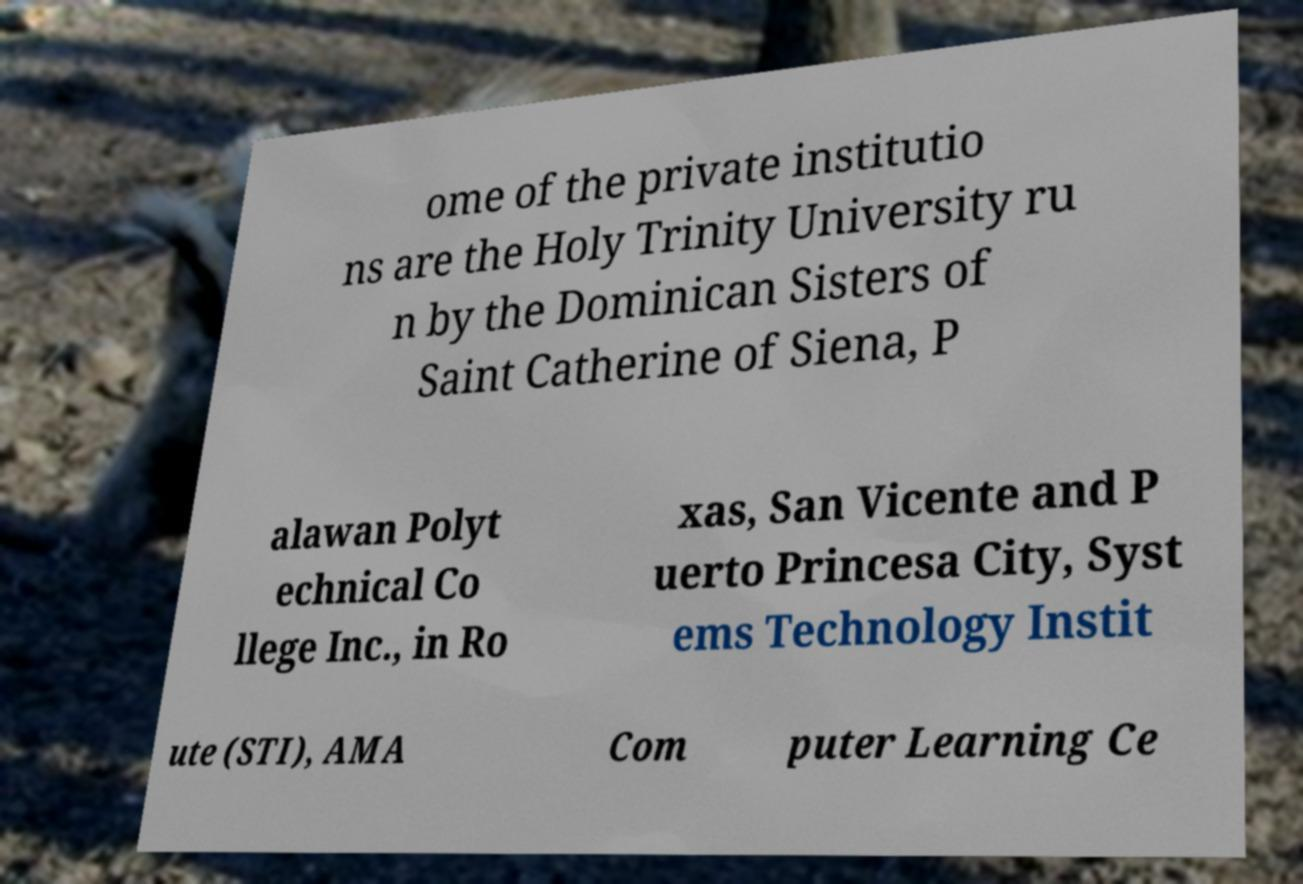Could you extract and type out the text from this image? ome of the private institutio ns are the Holy Trinity University ru n by the Dominican Sisters of Saint Catherine of Siena, P alawan Polyt echnical Co llege Inc., in Ro xas, San Vicente and P uerto Princesa City, Syst ems Technology Instit ute (STI), AMA Com puter Learning Ce 